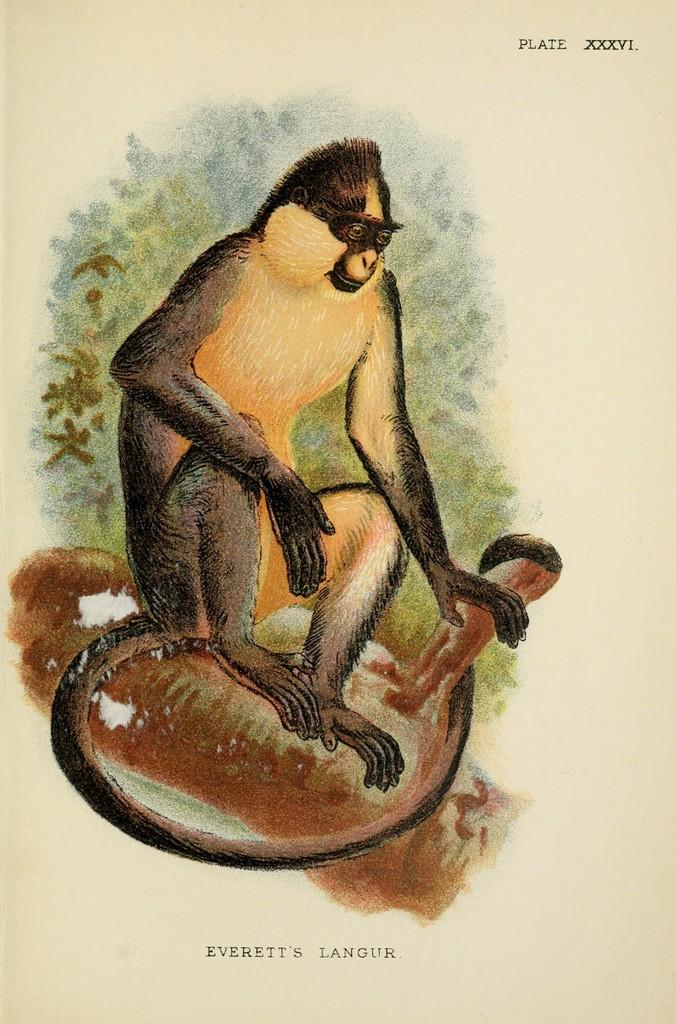What is depicted in the drawing in the picture? There is a drawing of a monkey in the picture. What is the color of the object on which the drawing is made? The drawing is on a brown-colored object. Where can text be found in the picture? There is text written in the bottom right corner and the top right corner of the picture. What type of polish is used to maintain the wren's feathers in the image? There is no wren or mention of polish in the image; it features a drawing of a monkey on a brown-colored object with text in the corners. 